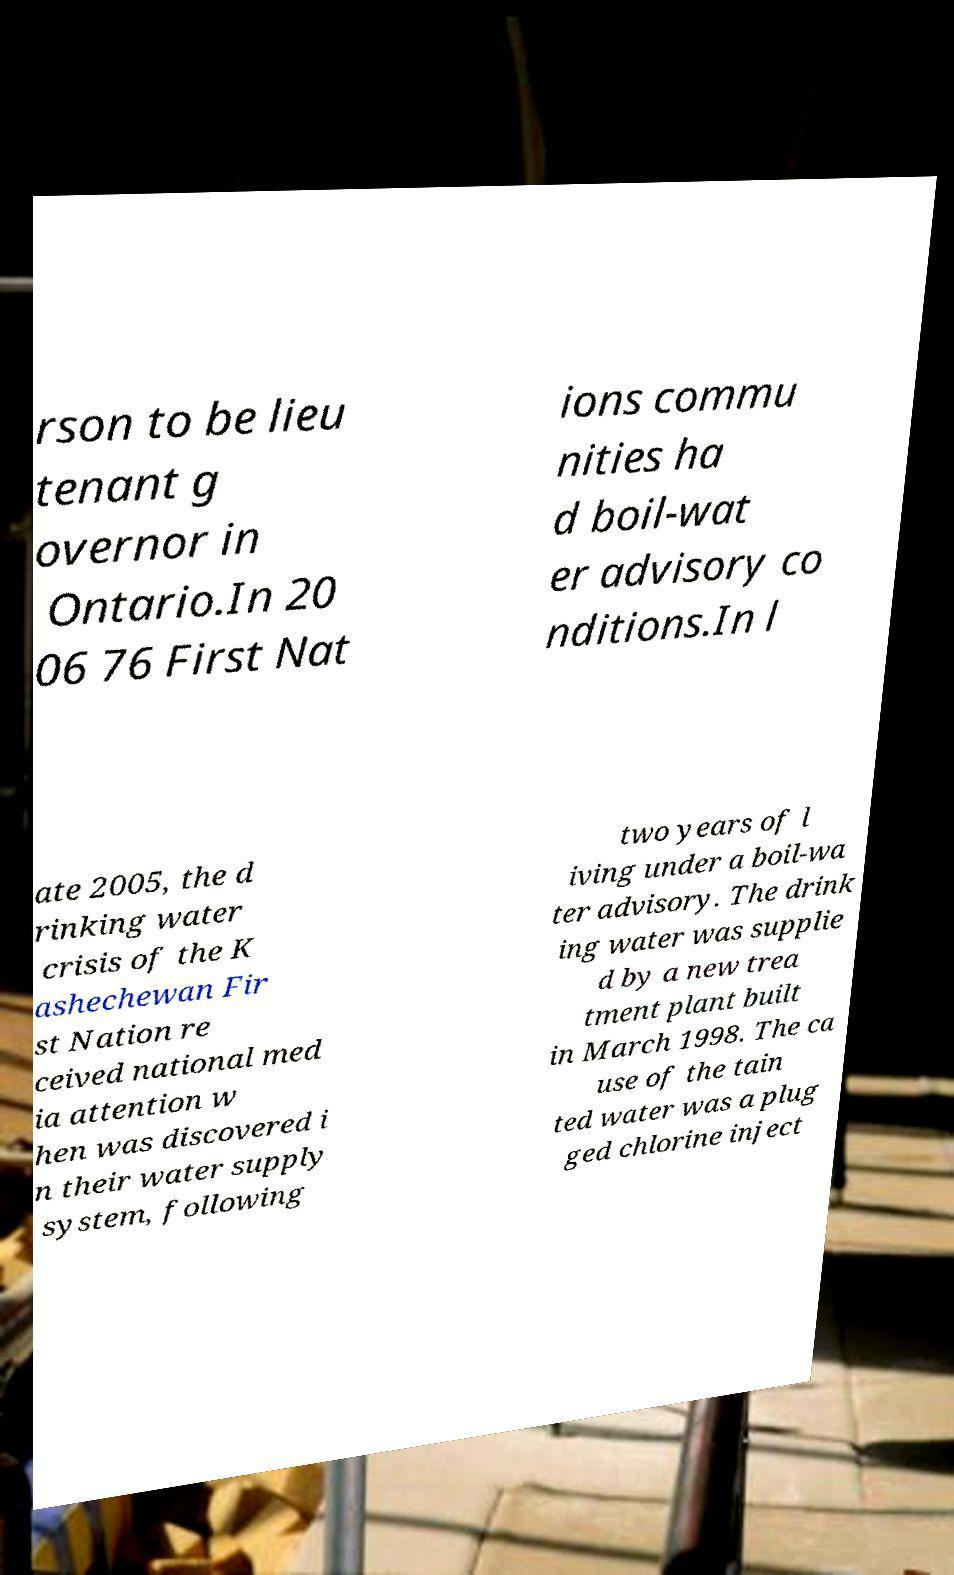For documentation purposes, I need the text within this image transcribed. Could you provide that? rson to be lieu tenant g overnor in Ontario.In 20 06 76 First Nat ions commu nities ha d boil-wat er advisory co nditions.In l ate 2005, the d rinking water crisis of the K ashechewan Fir st Nation re ceived national med ia attention w hen was discovered i n their water supply system, following two years of l iving under a boil-wa ter advisory. The drink ing water was supplie d by a new trea tment plant built in March 1998. The ca use of the tain ted water was a plug ged chlorine inject 